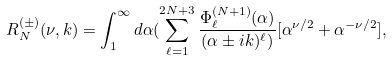Convert formula to latex. <formula><loc_0><loc_0><loc_500><loc_500>R ^ { ( \pm ) } _ { N } ( \nu , k ) = \int _ { 1 } ^ { \infty } d \alpha ( \sum _ { \ell = 1 } ^ { 2 N + 3 } \frac { \Phi ^ { ( N + 1 ) } _ { \ell } ( \alpha ) } { ( \alpha \pm i k ) ^ { \ell } ) } [ \alpha ^ { \nu / 2 } + \alpha ^ { - \nu / 2 } ] ,</formula> 